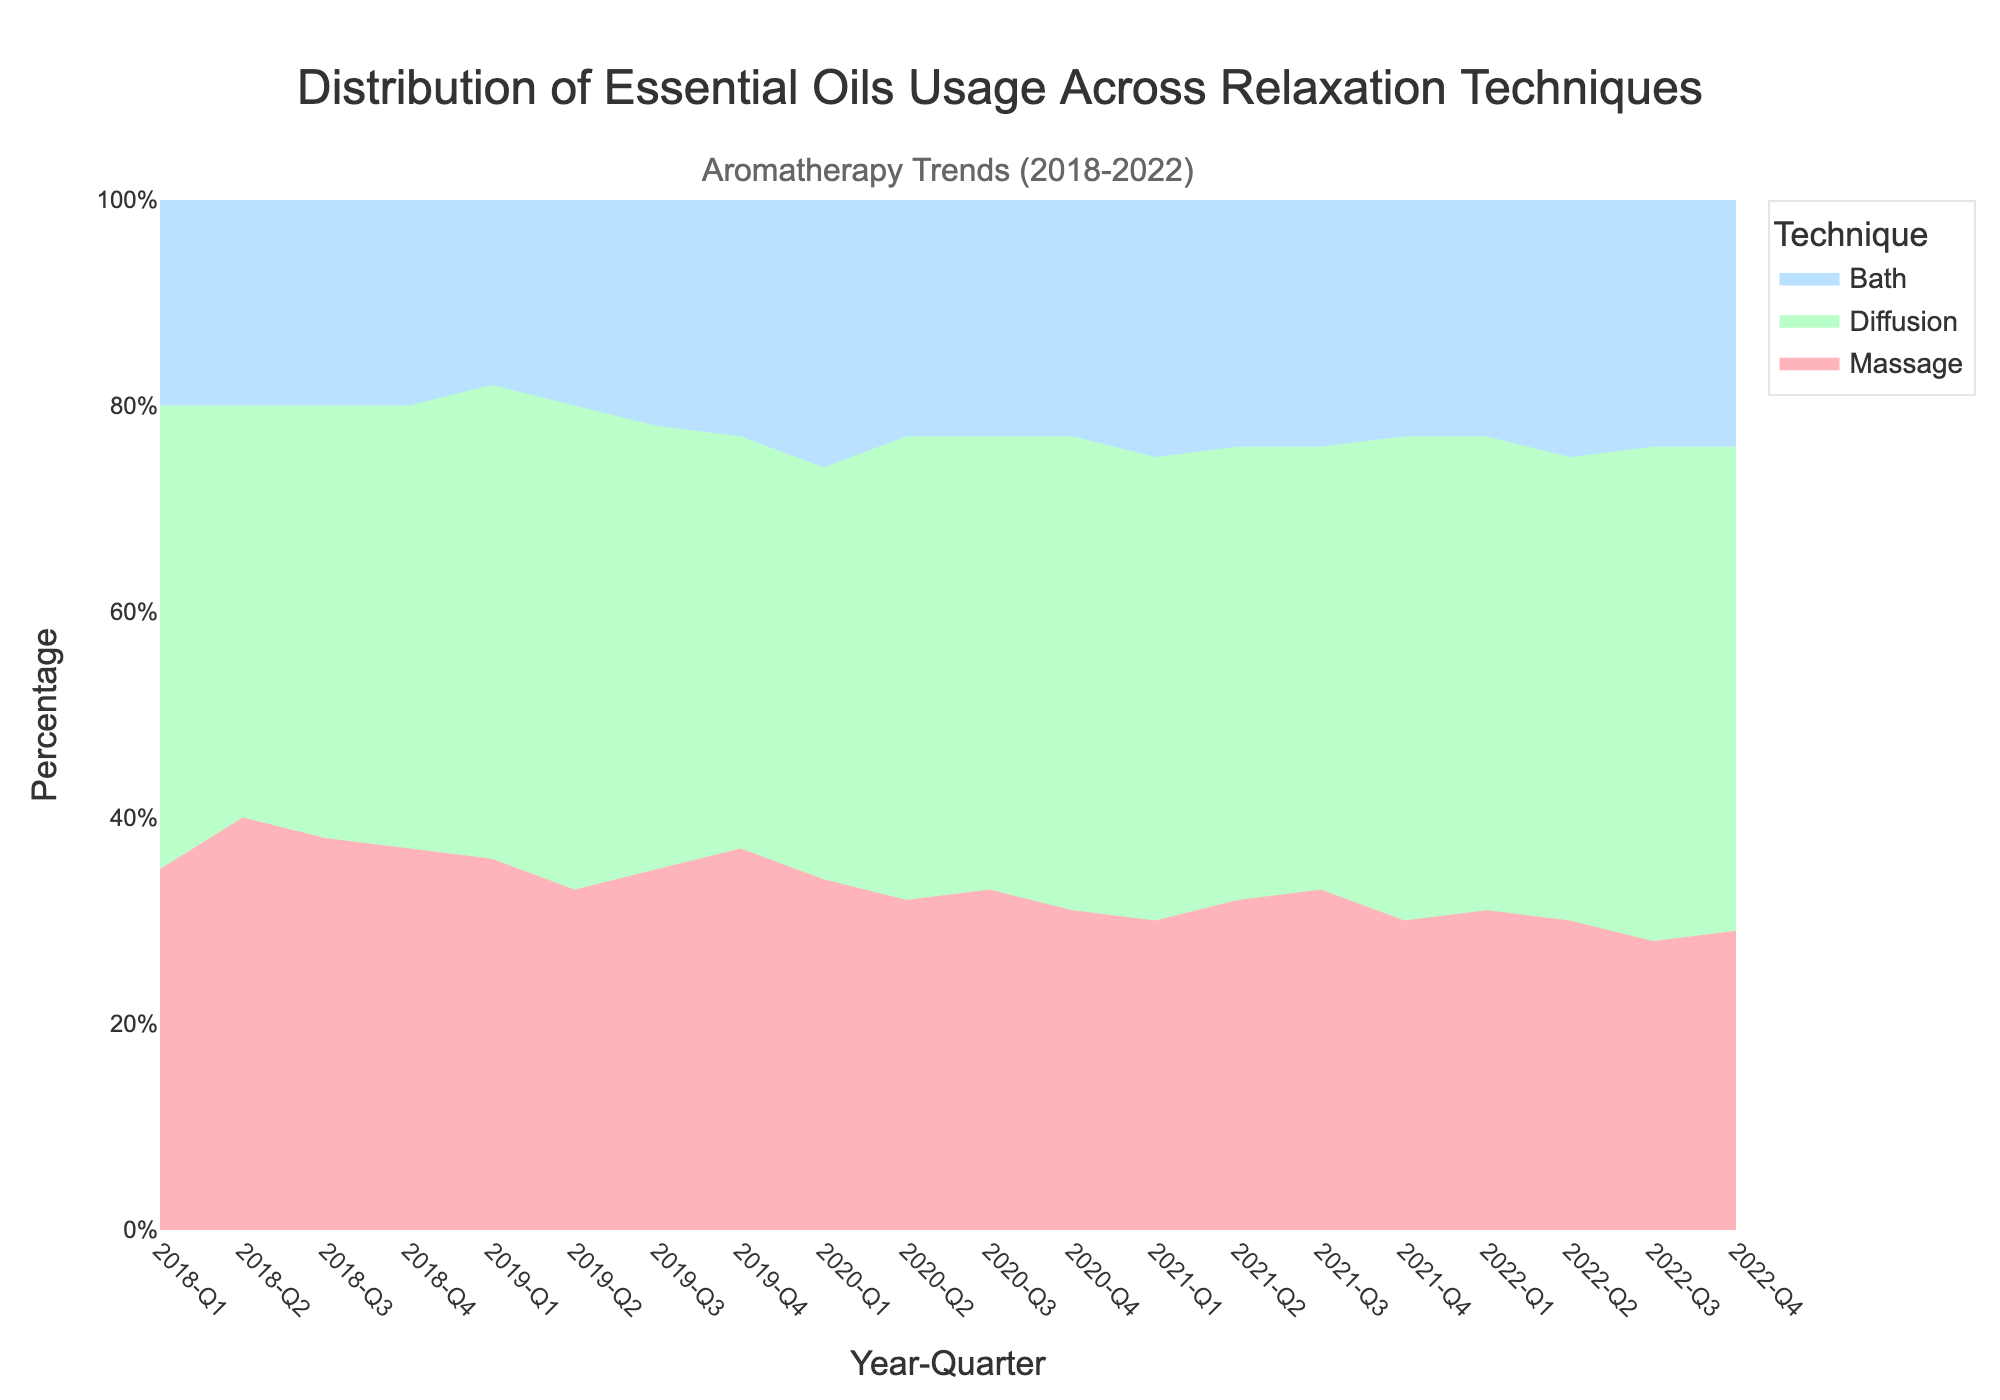What is the title of the figure? The title is usually located at the top of the figure and clearly describes what the figure represents.
Answer: "Distribution of Essential Oils Usage Across Relaxation Techniques" Which technique showed the highest percentage usage in Q1 2019? By tracing the figure to Q1 2019 on the x-axis and checking the heights of each stack for that quarter, we can see which technique has the highest percentage.
Answer: Diffusion How did the percentage of Bath usage change from Q1 2020 to Q4 2022? Locate Q1 2020 and Q4 2022 on the x-axis and observe the height of the Bath section for these quarters to see the change in percentage. In Q1 2020, Bath usage was 26%, and in Q4 2022, it was 24%. The change is calculated as 24% - 26%.
Answer: Decreased by 2% In which quarter did Massage usage drop to its lowest point? We need to scan through the Massage usage data across all quarters and identify the lowest point.
Answer: Q3 2022 How does the average percentage of Diffusion usage from 2018 to 2022 compare to the average percentage of Massage usage for the same period? Calculate the average percentage for each technique over all the quarters by summing up their percentages and dividing by the number of data points (20 quarters). Then compare the two averages.
Answer: The average percentage of Diffusion usage is higher than Massage usage What is the general trend of Diffusion usage from 2018 to 2022? Look at the pattern of Diffusion usage across the timeline from 2018 to 2022 to identify if it is increasing, decreasing, or fluctuating.
Answer: Increasing During which year did Bath usage become consistently above 20% in each quarter? Check each quarter of each year starting from 2018 and see in which year the Bath section was consistently above 20%.
Answer: 2020 Is there any quarter where all three relaxation techniques had the same percentage usage? Observe the figure to see if any quarter exists where all three stacked sections have equal heights.
Answer: No What was the percentage usage of Massage in Q4 2019? Locate Q4 2019 on the x-axis and check the height of the Massage section.
Answer: 37% Which technique showed the most stability in its usage percentages over the years? Compare the variation in heights for Massage, Diffusion, and Bath sections across all quarters. The technique with the least variation is the most stable.
Answer: Bath 